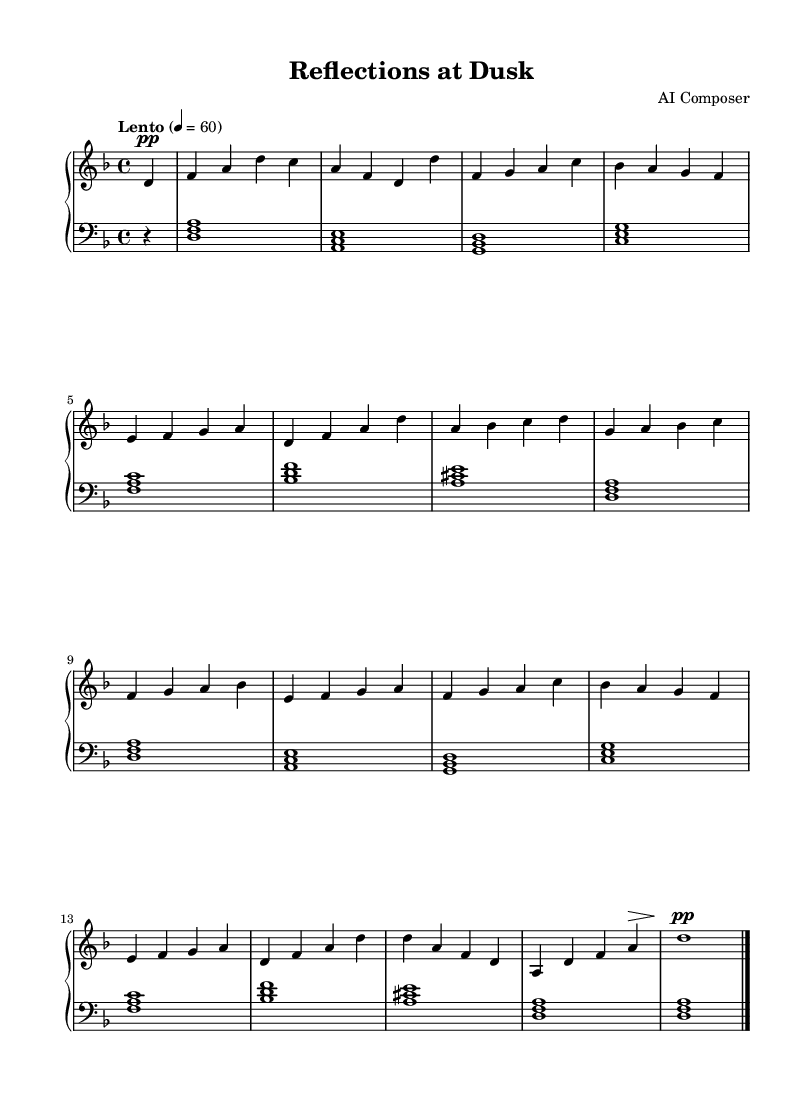What is the key signature of this music? The key signature shows two flats, indicating that the music is in D minor.
Answer: D minor What is the time signature of the piece? The time signature is indicated at the beginning of the staff and is 4/4, which means there are four beats per measure.
Answer: 4/4 What is the tempo marking given for the piece? The tempo marking is written as "Lento," which suggests a slow pace, and is indicated with a metronome marking of 60 beats per minute.
Answer: Lento How many measures are there in the piece? By counting the individual segments marked by the bar lines, there are a total of 14 measures in this piece.
Answer: 14 What note starts the right-hand melody? The melody in the right hand begins with a D note, which is the first note played after the rest.
Answer: D What is the highest note played in the left hand? The highest note played in the left hand is A, which can be found in measures featuring the chords where it is located.
Answer: A In which octave does the melody predominantly stay? The melody predominantly stays in the octave starting from the D5 note down to G4, indicating the use of mid to higher pitches typical in ambient piano music.
Answer: 4th octave 